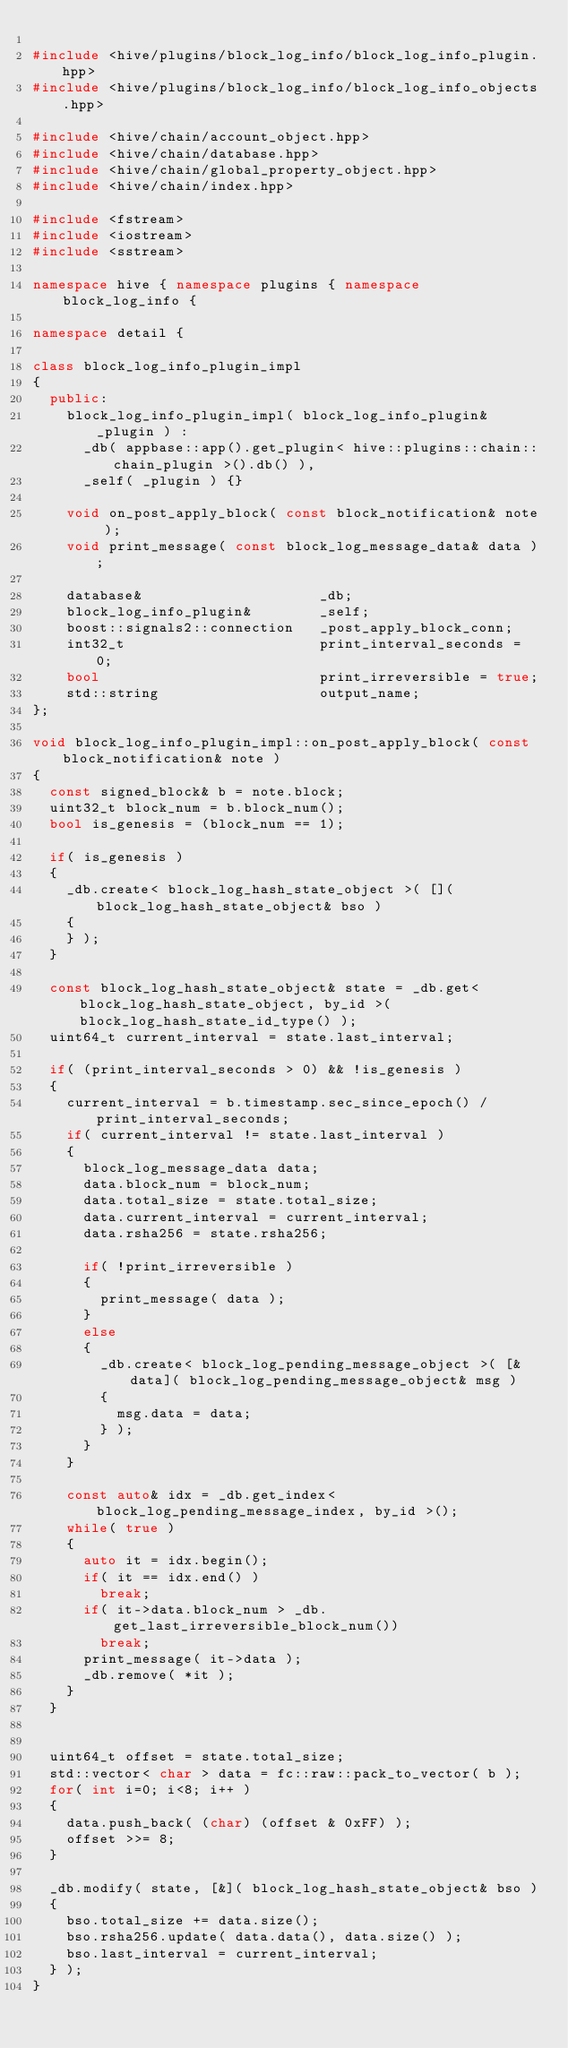<code> <loc_0><loc_0><loc_500><loc_500><_C++_>
#include <hive/plugins/block_log_info/block_log_info_plugin.hpp>
#include <hive/plugins/block_log_info/block_log_info_objects.hpp>

#include <hive/chain/account_object.hpp>
#include <hive/chain/database.hpp>
#include <hive/chain/global_property_object.hpp>
#include <hive/chain/index.hpp>

#include <fstream>
#include <iostream>
#include <sstream>

namespace hive { namespace plugins { namespace block_log_info {

namespace detail {

class block_log_info_plugin_impl
{
  public:
    block_log_info_plugin_impl( block_log_info_plugin& _plugin ) :
      _db( appbase::app().get_plugin< hive::plugins::chain::chain_plugin >().db() ),
      _self( _plugin ) {}

    void on_post_apply_block( const block_notification& note );
    void print_message( const block_log_message_data& data );

    database&                     _db;
    block_log_info_plugin&        _self;
    boost::signals2::connection   _post_apply_block_conn;
    int32_t                       print_interval_seconds = 0;
    bool                          print_irreversible = true;
    std::string                   output_name;
};

void block_log_info_plugin_impl::on_post_apply_block( const block_notification& note )
{
  const signed_block& b = note.block;
  uint32_t block_num = b.block_num();
  bool is_genesis = (block_num == 1);

  if( is_genesis )
  {
    _db.create< block_log_hash_state_object >( []( block_log_hash_state_object& bso )
    {
    } );
  }

  const block_log_hash_state_object& state = _db.get< block_log_hash_state_object, by_id >( block_log_hash_state_id_type() );
  uint64_t current_interval = state.last_interval;

  if( (print_interval_seconds > 0) && !is_genesis )
  {
    current_interval = b.timestamp.sec_since_epoch() / print_interval_seconds;
    if( current_interval != state.last_interval )
    {
      block_log_message_data data;
      data.block_num = block_num;
      data.total_size = state.total_size;
      data.current_interval = current_interval;
      data.rsha256 = state.rsha256;

      if( !print_irreversible )
      {
        print_message( data );
      }
      else
      {
        _db.create< block_log_pending_message_object >( [&data]( block_log_pending_message_object& msg )
        {
          msg.data = data;
        } );
      }
    }

    const auto& idx = _db.get_index< block_log_pending_message_index, by_id >();
    while( true )
    {
      auto it = idx.begin();
      if( it == idx.end() )
        break;
      if( it->data.block_num > _db.get_last_irreversible_block_num())
        break;
      print_message( it->data );
      _db.remove( *it );
    }
  }


  uint64_t offset = state.total_size;
  std::vector< char > data = fc::raw::pack_to_vector( b );
  for( int i=0; i<8; i++ )
  {
    data.push_back( (char) (offset & 0xFF) );
    offset >>= 8;
  }

  _db.modify( state, [&]( block_log_hash_state_object& bso )
  {
    bso.total_size += data.size();
    bso.rsha256.update( data.data(), data.size() );
    bso.last_interval = current_interval;
  } );
}
</code> 